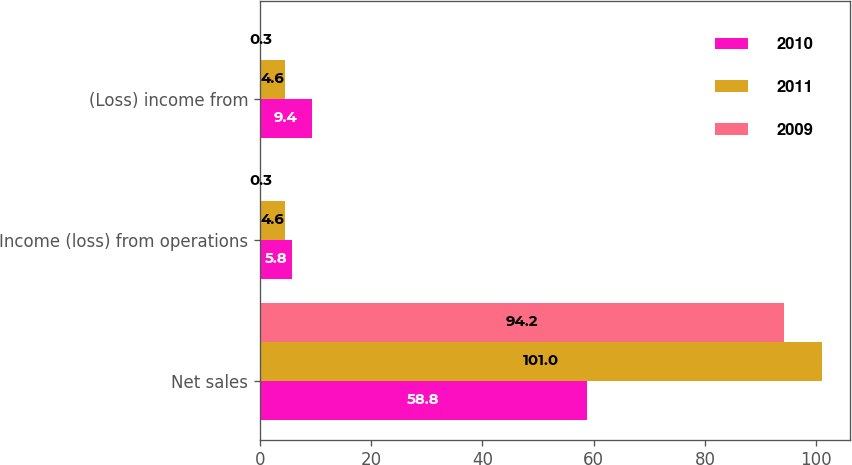Convert chart to OTSL. <chart><loc_0><loc_0><loc_500><loc_500><stacked_bar_chart><ecel><fcel>Net sales<fcel>Income (loss) from operations<fcel>(Loss) income from<nl><fcel>2010<fcel>58.8<fcel>5.8<fcel>9.4<nl><fcel>2011<fcel>101<fcel>4.6<fcel>4.6<nl><fcel>2009<fcel>94.2<fcel>0.3<fcel>0.3<nl></chart> 